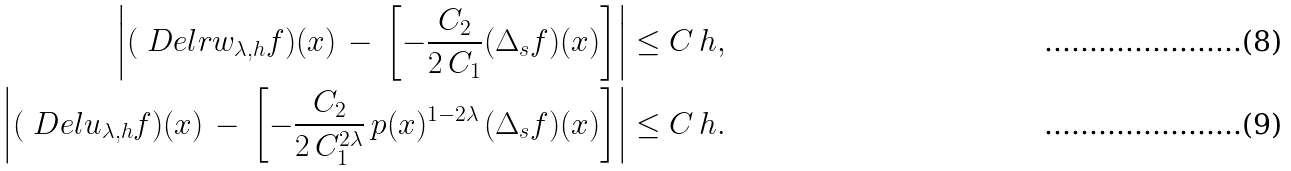Convert formula to latex. <formula><loc_0><loc_0><loc_500><loc_500>\left | ( \ D e l r w _ { \lambda , h } f ) ( x ) \, - \, \left [ - \frac { C _ { 2 } } { 2 \, C _ { 1 } } ( \Delta _ { s } f ) ( x ) \right ] \right | \leq C \, h , \\ \left | ( \ D e l u _ { \lambda , h } f ) ( x ) \, - \, \left [ - \frac { C _ { 2 } } { 2 \, C _ { 1 } ^ { 2 \lambda } } \, p ( x ) ^ { 1 - 2 \lambda } \, ( \Delta _ { s } f ) ( x ) \right ] \right | \leq C \, h .</formula> 